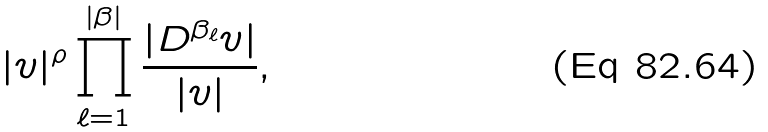Convert formula to latex. <formula><loc_0><loc_0><loc_500><loc_500>| v | ^ { \rho } \prod _ { \ell = 1 } ^ { | \beta | } \frac { | D ^ { \beta _ { \ell } } v | } { | v | } ,</formula> 